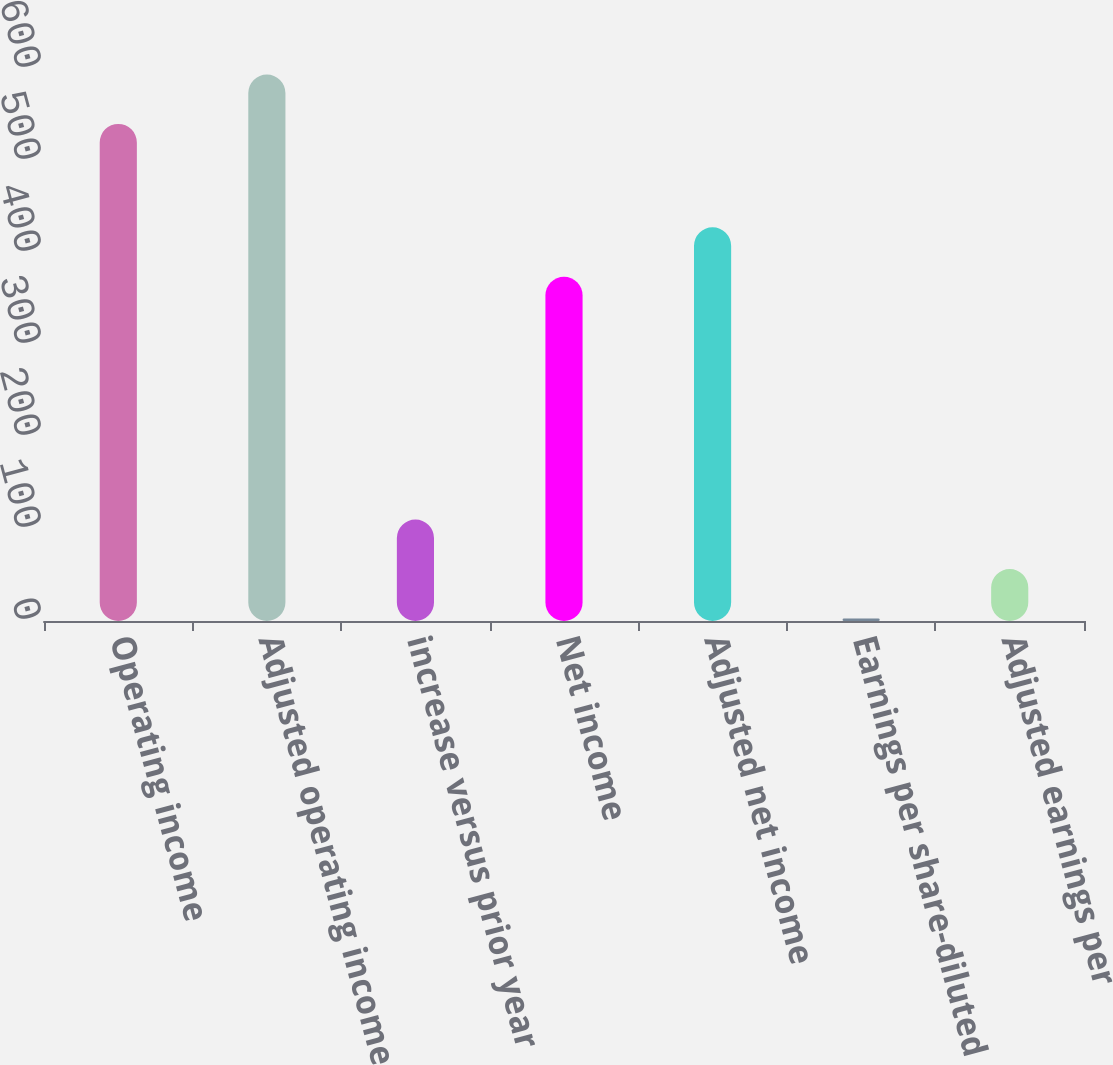<chart> <loc_0><loc_0><loc_500><loc_500><bar_chart><fcel>Operating income<fcel>Adjusted operating income<fcel>increase versus prior year<fcel>Net income<fcel>Adjusted net income<fcel>Earnings per share-diluted<fcel>Adjusted earnings per<nl><fcel>540.3<fcel>594.05<fcel>110.29<fcel>374.2<fcel>427.95<fcel>2.79<fcel>56.54<nl></chart> 